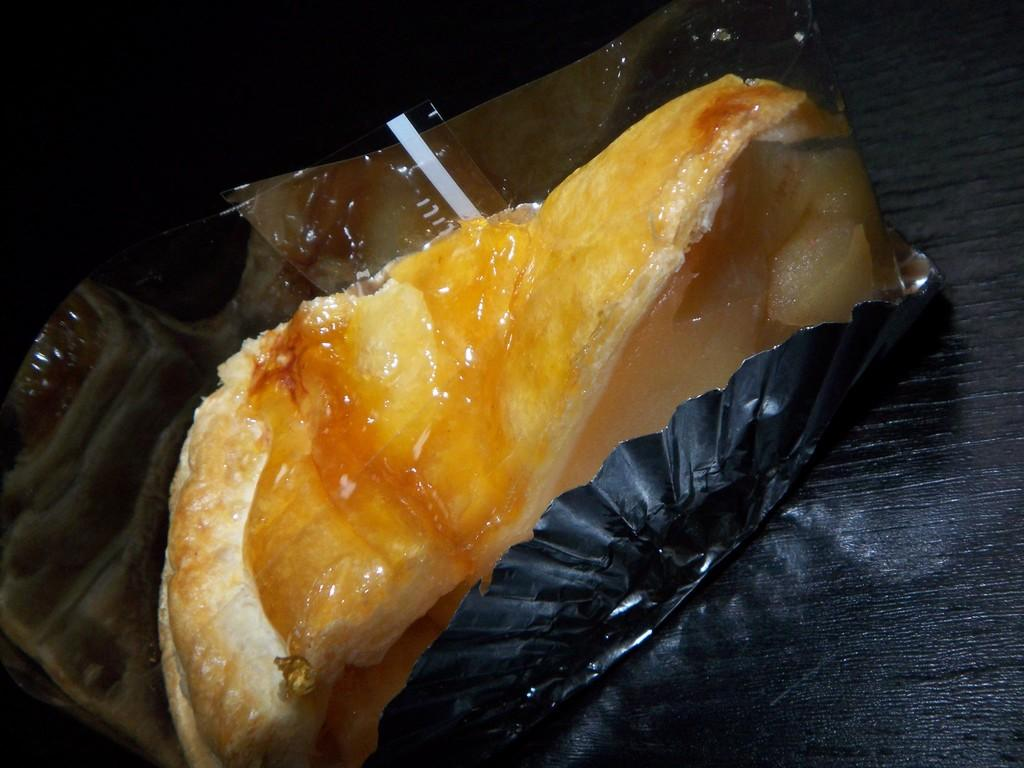What is the main subject of the image? There is a food item in the image. How is the food item presented? The food item is on a paper plate. What is the color of the table in the image? The table in the image is black in color. What type of arithmetic problem is being solved on the swing in the image? There is no swing or arithmetic problem present in the image. 